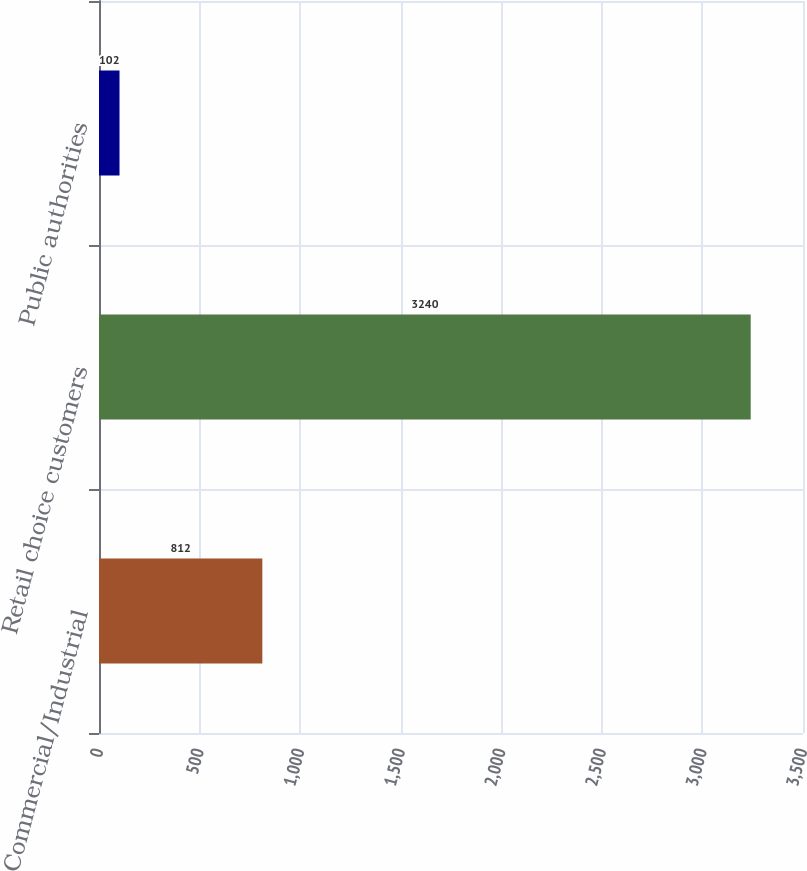Convert chart to OTSL. <chart><loc_0><loc_0><loc_500><loc_500><bar_chart><fcel>Commercial/Industrial<fcel>Retail choice customers<fcel>Public authorities<nl><fcel>812<fcel>3240<fcel>102<nl></chart> 